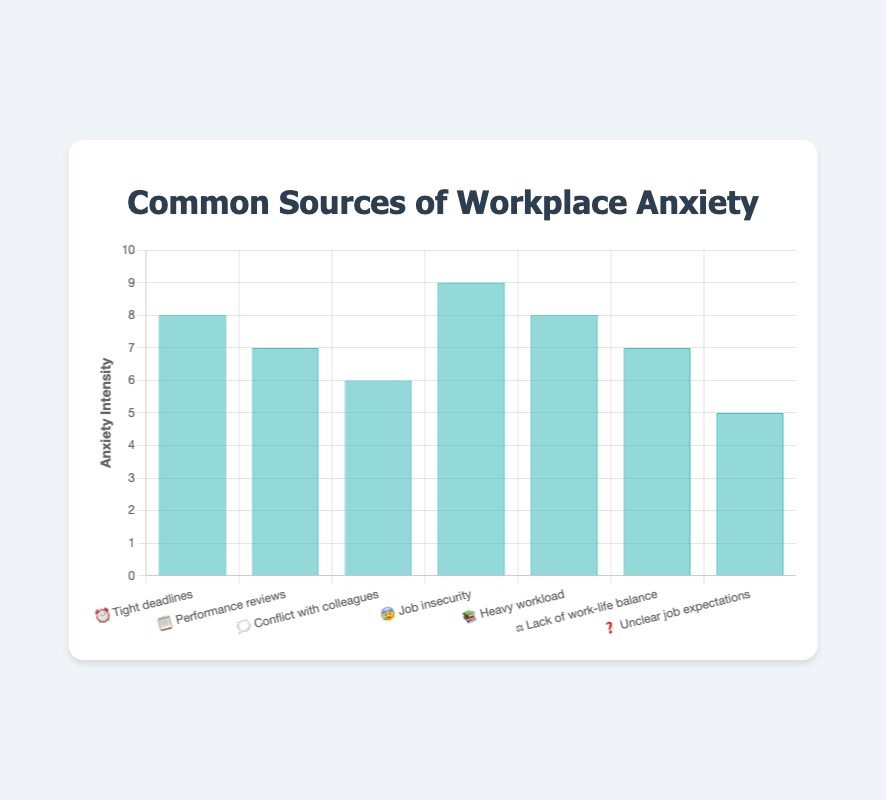Which source of workplace anxiety has the highest intensity? Look for the bar with the highest value on the vertical axis. The bar labeled "😰 Job insecurity" reaches the top intensity level of 9.
Answer: Job insecurity Which two sources of anxiety have the same intensity level of 8? Find the bars with the intensity level reaching 8. Both "⏰ Tight deadlines" and "📚 Heavy workload" have an intensity of 8.
Answer: Tight deadlines, Heavy workload What is the title of the chart? The title is displayed at the top of the chart in a larger, bold font. It reads "Common Sources of Workplace Anxiety".
Answer: Common Sources of Workplace Anxiety How many sources of workplace anxiety are shown in the chart? Count the number of distinct bars or labels along the horizontal axis. There are 7 labels corresponding to 7 sources.
Answer: 7 What is the intensity level of "⚖️ Lack of work-life balance"? Look at the height of the bar corresponding to the label "⚖️ Lack of work-life balance". It reaches an intensity level of 7.
Answer: 7 Which sources have an intensity less than 7? Identify the bars that do not reach the intensity mark of 7 on the vertical axis. Only "❓ Unclear job expectations" with an intensity of 5 fits this criterion.
Answer: Unclear job expectations How much higher is the intensity of "😰 Job insecurity" compared to "🗯️ Conflict with colleagues"? Subtract the intensity of "🗯️ Conflict with colleagues" (6) from that of "😰 Job insecurity" (9). The difference is 3.
Answer: 3 Arrange the sources of anxiety with an intensity of 7 in ascending order of their labels Find the sources with an intensity level of 7: "📋 Performance reviews" and "⚖️ Lack of work-life balance". Arrange them alphabetically by label.
Answer: Lack of work-life balance, Performance reviews Which source of anxiety has the lowest intensity? Identify the bar with the shortest height. "❓ Unclear job expectations" has the lowest intensity of 5.
Answer: Unclear job expectations 